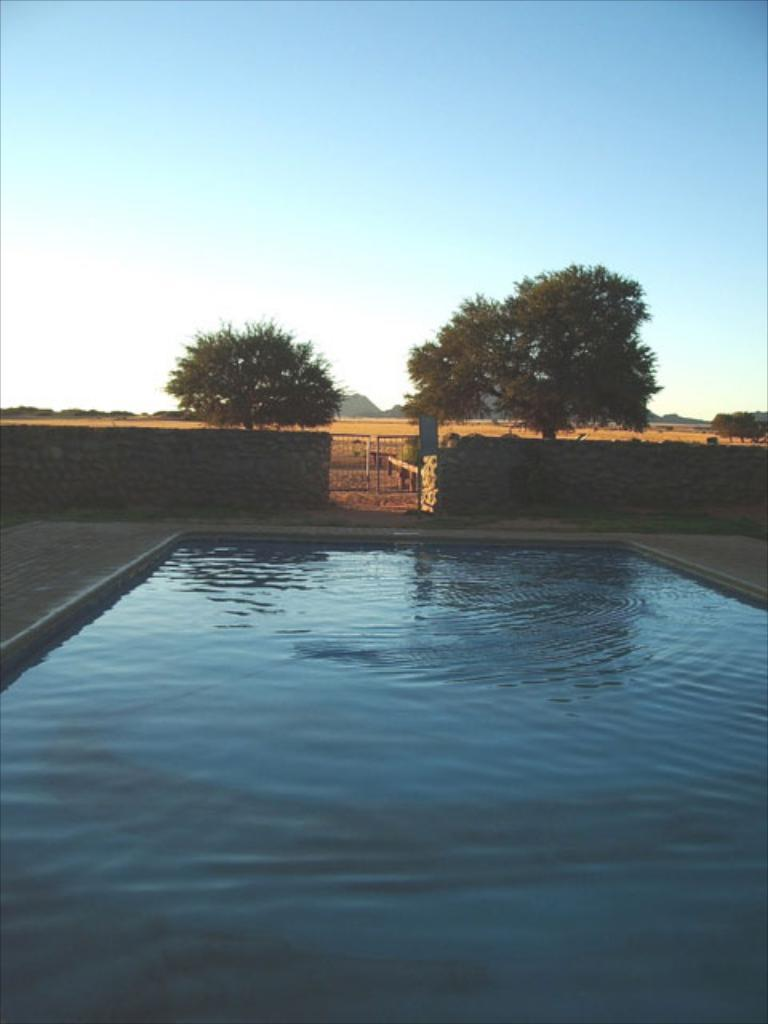What is the primary element present in the image? The image contains water. What can be seen in the background of the image? There is a wall, a gate, a board, trees, and sky visible in the background of the image. Can you describe the setting of the image? The image appears to be set outdoors, with water in the foreground and various structures and natural elements in the background. What type of smile can be seen on the minister's face in the image? There is no minister present in the image. 